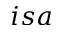<formula> <loc_0><loc_0><loc_500><loc_500>i s a</formula> 